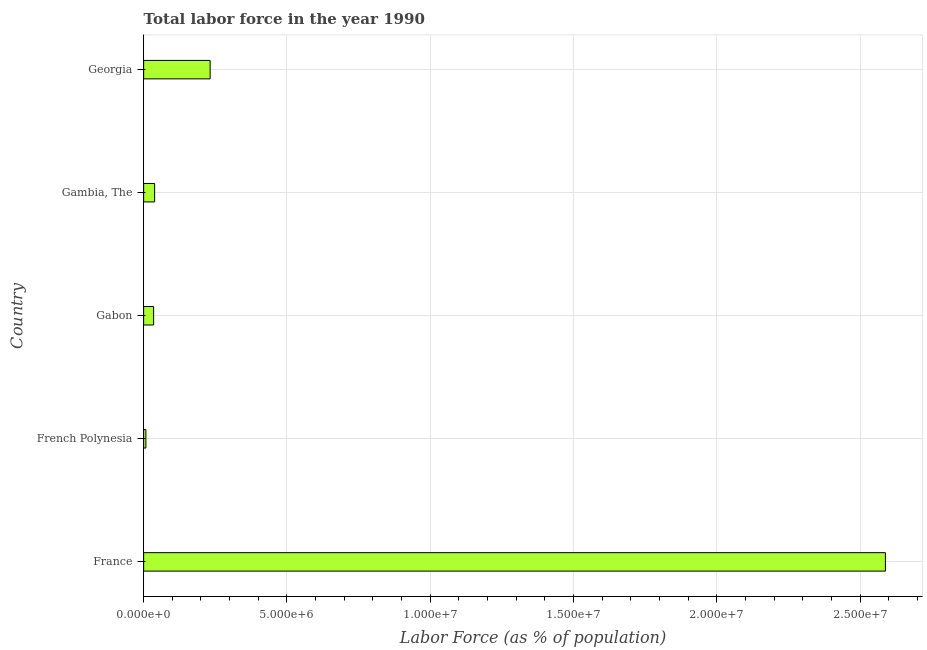Does the graph contain grids?
Provide a short and direct response. Yes. What is the title of the graph?
Provide a succinct answer. Total labor force in the year 1990. What is the label or title of the X-axis?
Offer a terse response. Labor Force (as % of population). What is the label or title of the Y-axis?
Your response must be concise. Country. What is the total labor force in Gabon?
Your answer should be compact. 3.48e+05. Across all countries, what is the maximum total labor force?
Keep it short and to the point. 2.59e+07. Across all countries, what is the minimum total labor force?
Ensure brevity in your answer.  7.81e+04. In which country was the total labor force minimum?
Provide a short and direct response. French Polynesia. What is the sum of the total labor force?
Give a very brief answer. 2.90e+07. What is the difference between the total labor force in Gabon and Georgia?
Provide a succinct answer. -1.97e+06. What is the average total labor force per country?
Your answer should be very brief. 5.80e+06. What is the median total labor force?
Your response must be concise. 3.83e+05. What is the ratio of the total labor force in France to that in Gambia, The?
Make the answer very short. 67.61. Is the total labor force in France less than that in Gabon?
Provide a short and direct response. No. What is the difference between the highest and the second highest total labor force?
Your answer should be very brief. 2.36e+07. What is the difference between the highest and the lowest total labor force?
Ensure brevity in your answer.  2.58e+07. In how many countries, is the total labor force greater than the average total labor force taken over all countries?
Ensure brevity in your answer.  1. How many bars are there?
Ensure brevity in your answer.  5. Are all the bars in the graph horizontal?
Your answer should be compact. Yes. How many countries are there in the graph?
Ensure brevity in your answer.  5. What is the difference between two consecutive major ticks on the X-axis?
Offer a terse response. 5.00e+06. What is the Labor Force (as % of population) in France?
Ensure brevity in your answer.  2.59e+07. What is the Labor Force (as % of population) in French Polynesia?
Offer a terse response. 7.81e+04. What is the Labor Force (as % of population) in Gabon?
Offer a terse response. 3.48e+05. What is the Labor Force (as % of population) in Gambia, The?
Offer a very short reply. 3.83e+05. What is the Labor Force (as % of population) in Georgia?
Your answer should be compact. 2.32e+06. What is the difference between the Labor Force (as % of population) in France and French Polynesia?
Give a very brief answer. 2.58e+07. What is the difference between the Labor Force (as % of population) in France and Gabon?
Give a very brief answer. 2.55e+07. What is the difference between the Labor Force (as % of population) in France and Gambia, The?
Provide a short and direct response. 2.55e+07. What is the difference between the Labor Force (as % of population) in France and Georgia?
Provide a succinct answer. 2.36e+07. What is the difference between the Labor Force (as % of population) in French Polynesia and Gabon?
Offer a very short reply. -2.70e+05. What is the difference between the Labor Force (as % of population) in French Polynesia and Gambia, The?
Your answer should be compact. -3.05e+05. What is the difference between the Labor Force (as % of population) in French Polynesia and Georgia?
Provide a short and direct response. -2.24e+06. What is the difference between the Labor Force (as % of population) in Gabon and Gambia, The?
Provide a short and direct response. -3.46e+04. What is the difference between the Labor Force (as % of population) in Gabon and Georgia?
Make the answer very short. -1.97e+06. What is the difference between the Labor Force (as % of population) in Gambia, The and Georgia?
Your response must be concise. -1.94e+06. What is the ratio of the Labor Force (as % of population) in France to that in French Polynesia?
Provide a short and direct response. 331.55. What is the ratio of the Labor Force (as % of population) in France to that in Gabon?
Your response must be concise. 74.32. What is the ratio of the Labor Force (as % of population) in France to that in Gambia, The?
Ensure brevity in your answer.  67.61. What is the ratio of the Labor Force (as % of population) in France to that in Georgia?
Offer a very short reply. 11.15. What is the ratio of the Labor Force (as % of population) in French Polynesia to that in Gabon?
Your response must be concise. 0.22. What is the ratio of the Labor Force (as % of population) in French Polynesia to that in Gambia, The?
Your response must be concise. 0.2. What is the ratio of the Labor Force (as % of population) in French Polynesia to that in Georgia?
Keep it short and to the point. 0.03. What is the ratio of the Labor Force (as % of population) in Gabon to that in Gambia, The?
Ensure brevity in your answer.  0.91. What is the ratio of the Labor Force (as % of population) in Gambia, The to that in Georgia?
Your response must be concise. 0.17. 